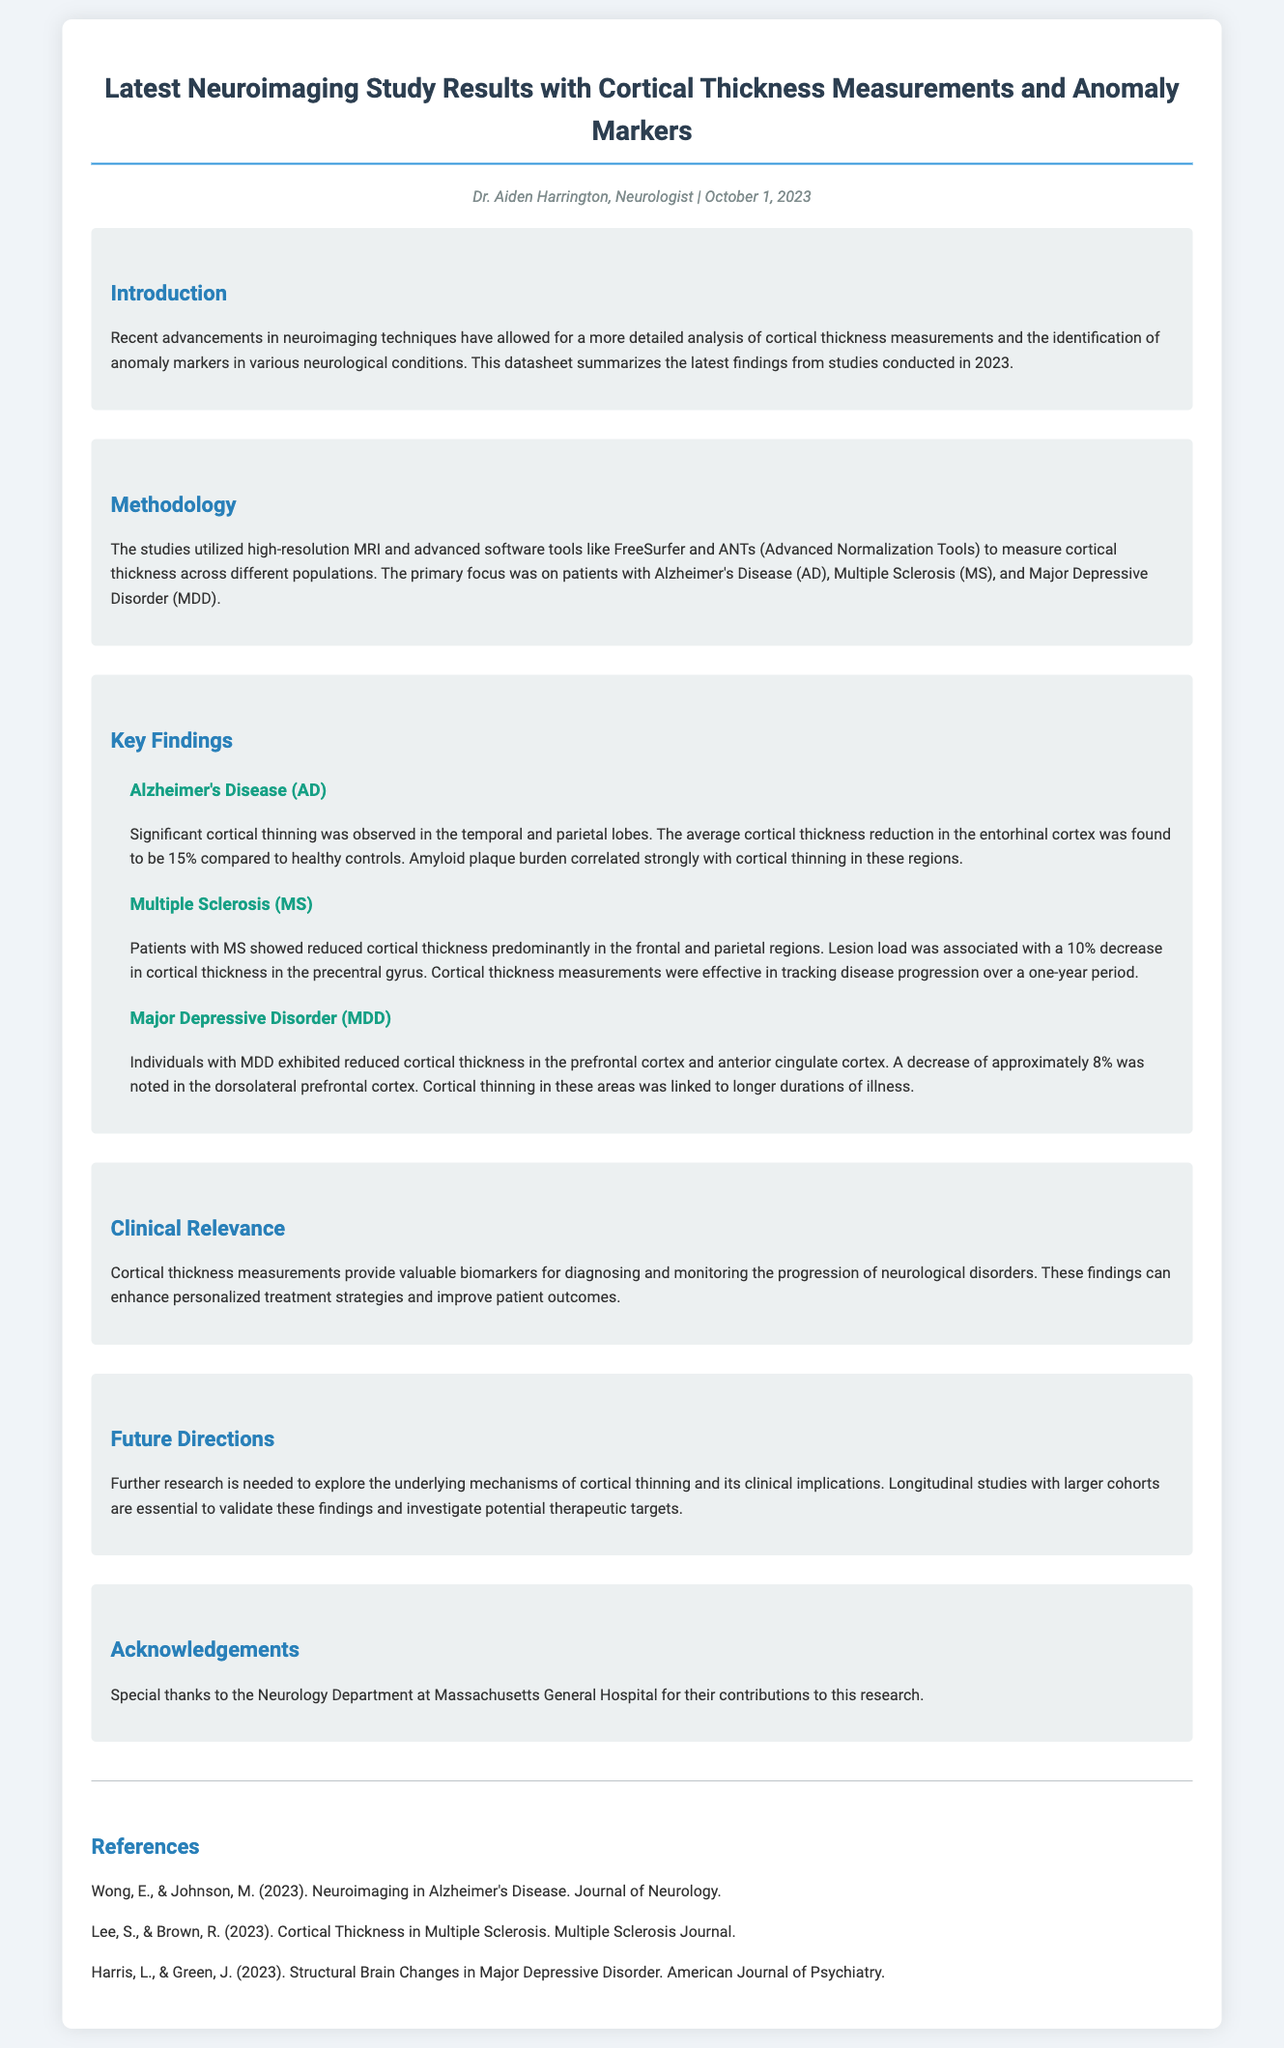What is the title of the datasheet? The title of the datasheet is located at the top of the document under the header section.
Answer: Latest Neuroimaging Study Results with Cortical Thickness Measurements and Anomaly Markers Who is the author of the document? The author of the document is specified in the author-date section just below the title.
Answer: Dr. Aiden Harrington What is the date of publication? The publication date is mentioned alongside the author's name in the author-date section.
Answer: October 1, 2023 What percentage reduction in cortical thickness was found in the entorhinal cortex for Alzheimer's Disease? This information is presented in the key findings for Alzheimer's Disease under the corresponding subsection.
Answer: 15% Which two brain regions showed reduced cortical thickness in patients with Major Depressive Disorder? This detail is found in the MDD subsection under key findings, summarizing affected areas.
Answer: prefrontal cortex and anterior cingulate cortex How much reduction in cortical thickness was associated with lesion load in Multiple Sclerosis? The specific percentage reduction is provided in the section on Multiple Sclerosis.
Answer: 10% What kind of neuroimaging technique was primarily utilized in these studies? This is outlined in the methodology section where techniques used in the research are described.
Answer: high-resolution MRI What is the main clinical relevance of cortical thickness measurements as stated in the document? The clinical relevance is highlighted in its own section, summarizing key importance.
Answer: valuable biomarkers for diagnosing and monitoring the progression of neurological disorders What are the suggested future directions for research? Future directions are mentioned at the end of the document, proposing areas of continued research.
Answer: explore underlying mechanisms of cortical thinning 